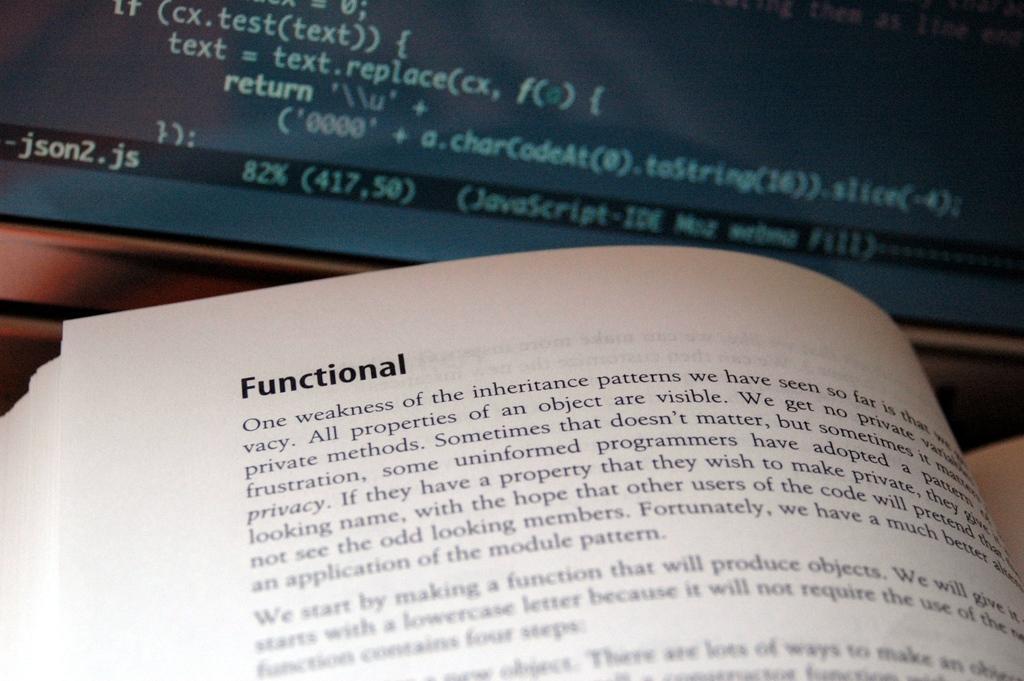Describe this image in one or two sentences. In this image we can see a book opened and on the book we can see some text. At the top we can see a screen on which we have some text. 